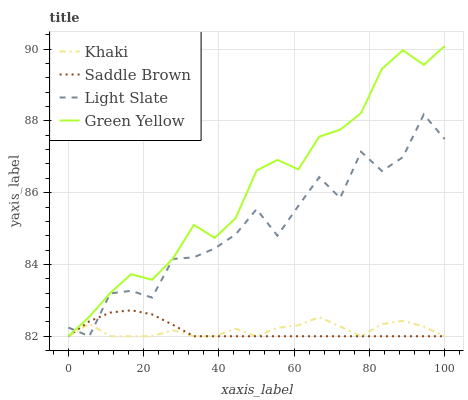Does Saddle Brown have the minimum area under the curve?
Answer yes or no. Yes. Does Green Yellow have the maximum area under the curve?
Answer yes or no. Yes. Does Khaki have the minimum area under the curve?
Answer yes or no. No. Does Khaki have the maximum area under the curve?
Answer yes or no. No. Is Saddle Brown the smoothest?
Answer yes or no. Yes. Is Light Slate the roughest?
Answer yes or no. Yes. Is Green Yellow the smoothest?
Answer yes or no. No. Is Green Yellow the roughest?
Answer yes or no. No. Does Light Slate have the lowest value?
Answer yes or no. Yes. Does Green Yellow have the highest value?
Answer yes or no. Yes. Does Khaki have the highest value?
Answer yes or no. No. Does Green Yellow intersect Saddle Brown?
Answer yes or no. Yes. Is Green Yellow less than Saddle Brown?
Answer yes or no. No. Is Green Yellow greater than Saddle Brown?
Answer yes or no. No. 